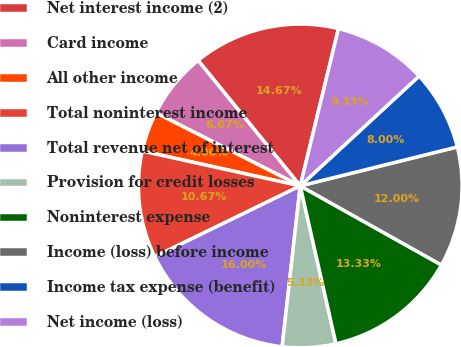Convert chart. <chart><loc_0><loc_0><loc_500><loc_500><pie_chart><fcel>Net interest income (2)<fcel>Card income<fcel>All other income<fcel>Total noninterest income<fcel>Total revenue net of interest<fcel>Provision for credit losses<fcel>Noninterest expense<fcel>Income (loss) before income<fcel>Income tax expense (benefit)<fcel>Net income (loss)<nl><fcel>14.67%<fcel>6.67%<fcel>4.0%<fcel>10.67%<fcel>16.0%<fcel>5.33%<fcel>13.33%<fcel>12.0%<fcel>8.0%<fcel>9.33%<nl></chart> 